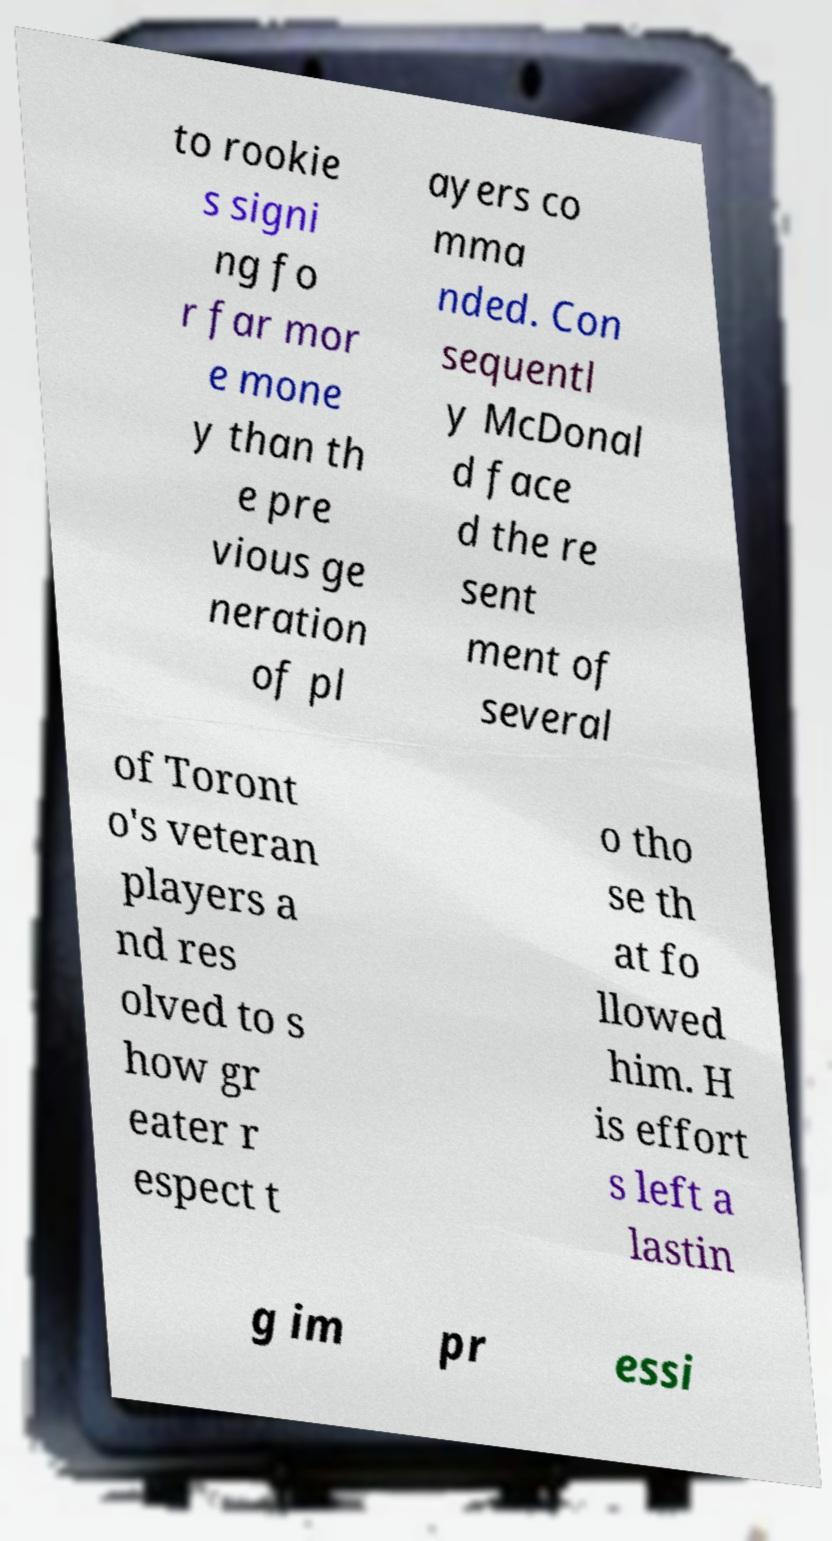Could you assist in decoding the text presented in this image and type it out clearly? to rookie s signi ng fo r far mor e mone y than th e pre vious ge neration of pl ayers co mma nded. Con sequentl y McDonal d face d the re sent ment of several of Toront o's veteran players a nd res olved to s how gr eater r espect t o tho se th at fo llowed him. H is effort s left a lastin g im pr essi 